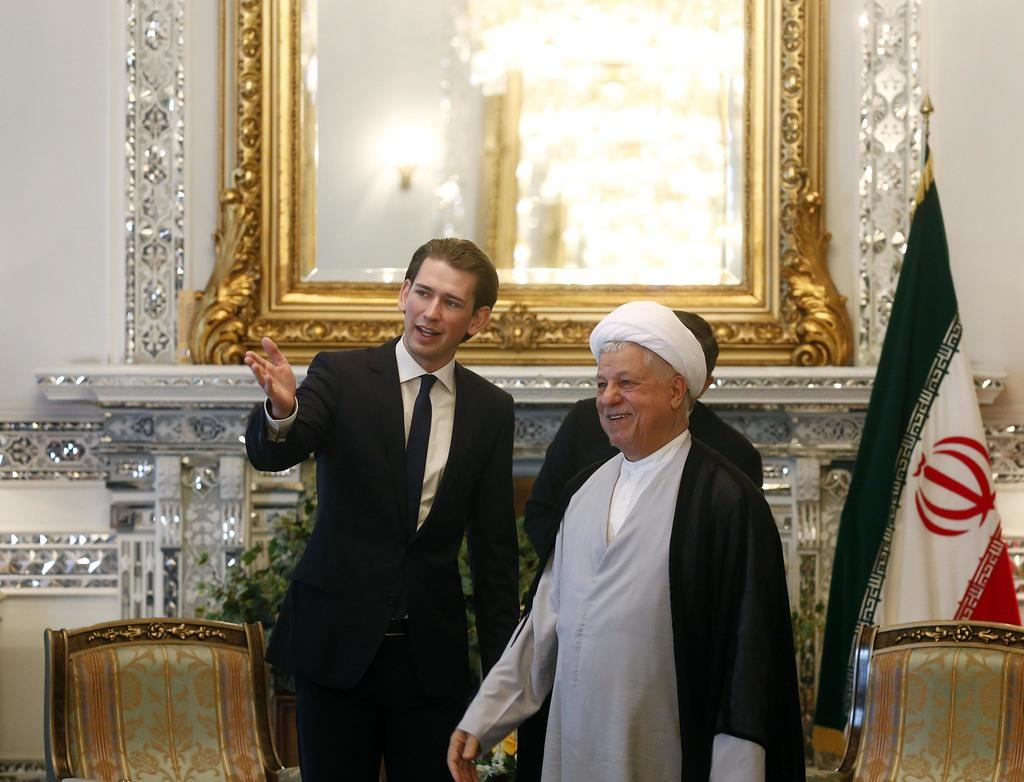What can be observed about the people in the image? There are people standing in the image. What are some of the people wearing? Some people are wearing suits. Where is the flag located in the image? The flag is on the right side of the image. What object allows for self-reflection in the image? There is a mirror visible in the image. What type of furniture is present in the image? Chairs are present in the image. How many visitors can be seen interacting with the drawer in the image? There is no drawer present in the image, and therefore no visitors interacting with it. 